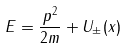<formula> <loc_0><loc_0><loc_500><loc_500>E = \frac { p ^ { 2 } } { 2 m } + U _ { \pm } ( x )</formula> 